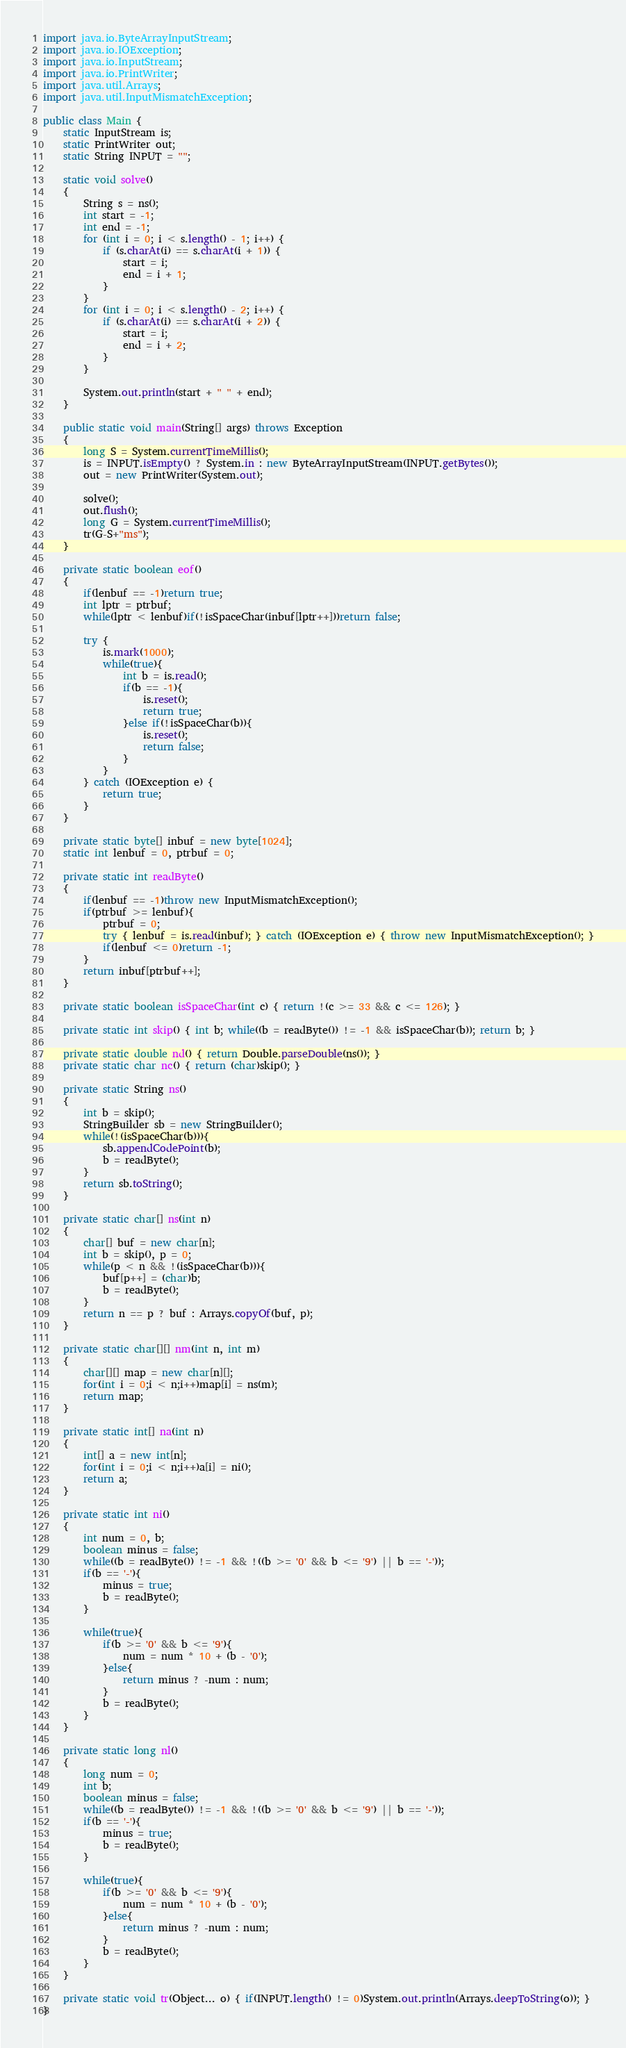<code> <loc_0><loc_0><loc_500><loc_500><_Java_>import java.io.ByteArrayInputStream;
import java.io.IOException;
import java.io.InputStream;
import java.io.PrintWriter;
import java.util.Arrays;
import java.util.InputMismatchException;

public class Main {
    static InputStream is;
    static PrintWriter out;
    static String INPUT = "";

    static void solve()
    {
        String s = ns();
        int start = -1;
        int end = -1;
        for (int i = 0; i < s.length() - 1; i++) {
            if (s.charAt(i) == s.charAt(i + 1)) {
                start = i;
                end = i + 1;
            }
        }
        for (int i = 0; i < s.length() - 2; i++) {
            if (s.charAt(i) == s.charAt(i + 2)) {
                start = i;
                end = i + 2;
            }
        }

        System.out.println(start + " " + end);
    }

    public static void main(String[] args) throws Exception
    {
        long S = System.currentTimeMillis();
        is = INPUT.isEmpty() ? System.in : new ByteArrayInputStream(INPUT.getBytes());
        out = new PrintWriter(System.out);

        solve();
        out.flush();
        long G = System.currentTimeMillis();
        tr(G-S+"ms");
    }

    private static boolean eof()
    {
        if(lenbuf == -1)return true;
        int lptr = ptrbuf;
        while(lptr < lenbuf)if(!isSpaceChar(inbuf[lptr++]))return false;

        try {
            is.mark(1000);
            while(true){
                int b = is.read();
                if(b == -1){
                    is.reset();
                    return true;
                }else if(!isSpaceChar(b)){
                    is.reset();
                    return false;
                }
            }
        } catch (IOException e) {
            return true;
        }
    }

    private static byte[] inbuf = new byte[1024];
    static int lenbuf = 0, ptrbuf = 0;

    private static int readByte()
    {
        if(lenbuf == -1)throw new InputMismatchException();
        if(ptrbuf >= lenbuf){
            ptrbuf = 0;
            try { lenbuf = is.read(inbuf); } catch (IOException e) { throw new InputMismatchException(); }
            if(lenbuf <= 0)return -1;
        }
        return inbuf[ptrbuf++];
    }

    private static boolean isSpaceChar(int c) { return !(c >= 33 && c <= 126); }

    private static int skip() { int b; while((b = readByte()) != -1 && isSpaceChar(b)); return b; }

    private static double nd() { return Double.parseDouble(ns()); }
    private static char nc() { return (char)skip(); }

    private static String ns()
    {
        int b = skip();
        StringBuilder sb = new StringBuilder();
        while(!(isSpaceChar(b))){
            sb.appendCodePoint(b);
            b = readByte();
        }
        return sb.toString();
    }

    private static char[] ns(int n)
    {
        char[] buf = new char[n];
        int b = skip(), p = 0;
        while(p < n && !(isSpaceChar(b))){
            buf[p++] = (char)b;
            b = readByte();
        }
        return n == p ? buf : Arrays.copyOf(buf, p);
    }

    private static char[][] nm(int n, int m)
    {
        char[][] map = new char[n][];
        for(int i = 0;i < n;i++)map[i] = ns(m);
        return map;
    }

    private static int[] na(int n)
    {
        int[] a = new int[n];
        for(int i = 0;i < n;i++)a[i] = ni();
        return a;
    }

    private static int ni()
    {
        int num = 0, b;
        boolean minus = false;
        while((b = readByte()) != -1 && !((b >= '0' && b <= '9') || b == '-'));
        if(b == '-'){
            minus = true;
            b = readByte();
        }

        while(true){
            if(b >= '0' && b <= '9'){
                num = num * 10 + (b - '0');
            }else{
                return minus ? -num : num;
            }
            b = readByte();
        }
    }

    private static long nl()
    {
        long num = 0;
        int b;
        boolean minus = false;
        while((b = readByte()) != -1 && !((b >= '0' && b <= '9') || b == '-'));
        if(b == '-'){
            minus = true;
            b = readByte();
        }

        while(true){
            if(b >= '0' && b <= '9'){
                num = num * 10 + (b - '0');
            }else{
                return minus ? -num : num;
            }
            b = readByte();
        }
    }

    private static void tr(Object... o) { if(INPUT.length() != 0)System.out.println(Arrays.deepToString(o)); }
}

</code> 